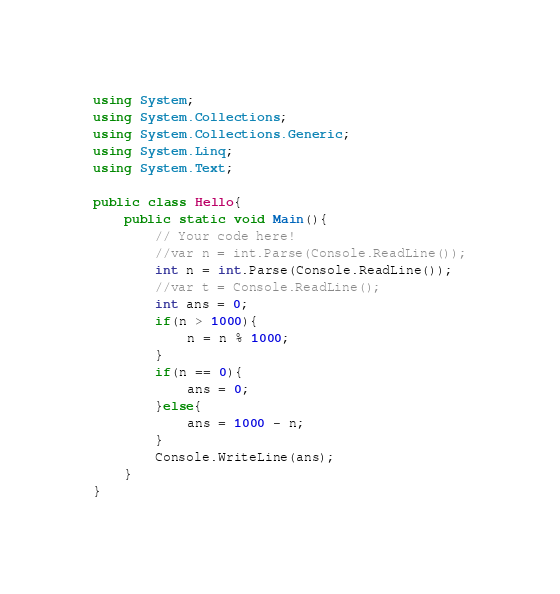Convert code to text. <code><loc_0><loc_0><loc_500><loc_500><_C#_>using System;
using System.Collections;
using System.Collections.Generic;
using System.Linq;
using System.Text;

public class Hello{
    public static void Main(){
        // Your code here!
        //var n = int.Parse(Console.ReadLine());
        int n = int.Parse(Console.ReadLine());
        //var t = Console.ReadLine();
        int ans = 0;
        if(n > 1000){
            n = n % 1000;
        }
        if(n == 0){
            ans = 0;
        }else{
            ans = 1000 - n;
        }
        Console.WriteLine(ans);
    }
}
</code> 